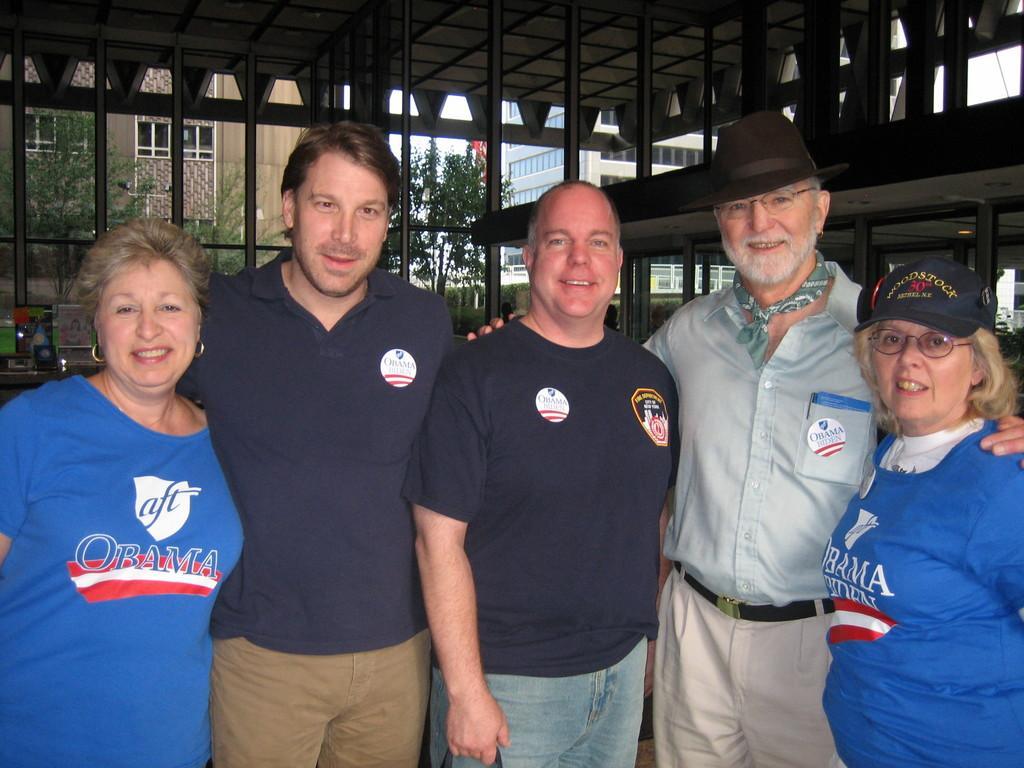How would you summarize this image in a sentence or two? In this image we can see there are people standing and at the back we can see the shed and few objects. There are buildings and trees in the background. 